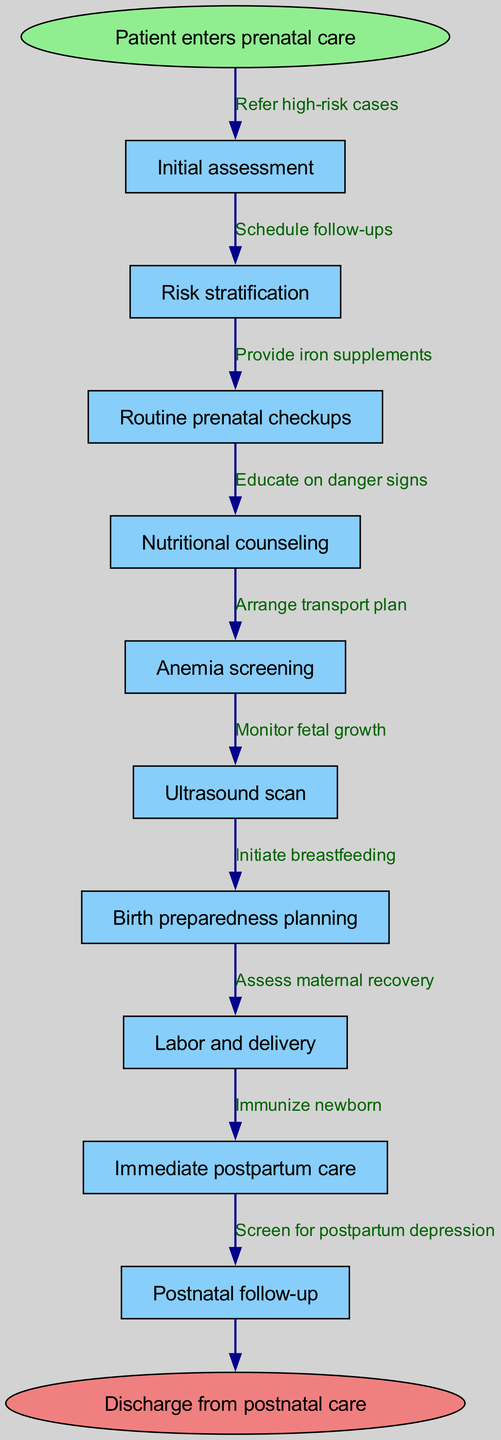What is the starting point of the pathway? The starting point of the pathway is indicated as the first node labeled "Patient enters prenatal care."
Answer: Patient enters prenatal care How many nodes are in the diagram? Counting all the nodes listed, there are 10 nodes representing different stages in the clinical pathway.
Answer: 10 Which node comes after "Routine prenatal checkups"? The node that follows "Routine prenatal checkups" is "Nutritional counseling," which is the next step in the pathway.
Answer: Nutritional counseling What is the last point before discharge? The last point before discharge is "Postnatal follow-up," which is the final stage before the patient is discharged from care.
Answer: Postnatal follow-up What process is initiated immediately after delivery? Immediately after delivery, the process "Immediate postpartum care" is initiated to provide necessary care to the mother and child.
Answer: Immediate postpartum care How many edges are there in the diagram? There are 10 edges that connect all the nodes in the clinical pathway, illustrating the flow of care.
Answer: 10 Which node is responsible for educating on danger signs? The node "Birth preparedness planning" is responsible for educating patients on danger signs during the context of childbirth.
Answer: Birth preparedness planning What step comes before maternal recovery assessment? The step that comes before assessing maternal recovery is "Immediate postpartum care," which focuses on the mother's early recovery.
Answer: Immediate postpartum care From which node are high-risk cases referred? High-risk cases are referred after the "Risk stratification" node, which identifies which patients require additional care.
Answer: Risk stratification 